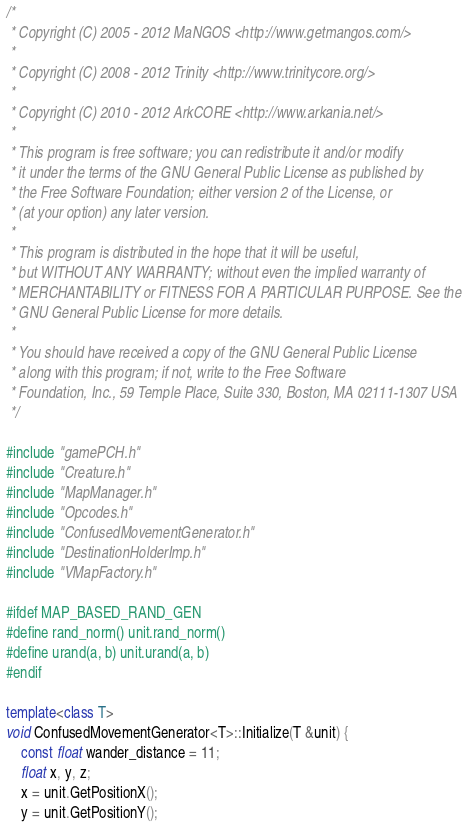Convert code to text. <code><loc_0><loc_0><loc_500><loc_500><_C++_>/*
 * Copyright (C) 2005 - 2012 MaNGOS <http://www.getmangos.com/>
 *
 * Copyright (C) 2008 - 2012 Trinity <http://www.trinitycore.org/>
 *
 * Copyright (C) 2010 - 2012 ArkCORE <http://www.arkania.net/>
 *
 * This program is free software; you can redistribute it and/or modify
 * it under the terms of the GNU General Public License as published by
 * the Free Software Foundation; either version 2 of the License, or
 * (at your option) any later version.
 *
 * This program is distributed in the hope that it will be useful,
 * but WITHOUT ANY WARRANTY; without even the implied warranty of
 * MERCHANTABILITY or FITNESS FOR A PARTICULAR PURPOSE. See the
 * GNU General Public License for more details.
 *
 * You should have received a copy of the GNU General Public License
 * along with this program; if not, write to the Free Software
 * Foundation, Inc., 59 Temple Place, Suite 330, Boston, MA 02111-1307 USA
 */

#include "gamePCH.h"
#include "Creature.h"
#include "MapManager.h"
#include "Opcodes.h"
#include "ConfusedMovementGenerator.h"
#include "DestinationHolderImp.h"
#include "VMapFactory.h"

#ifdef MAP_BASED_RAND_GEN
#define rand_norm() unit.rand_norm()
#define urand(a, b) unit.urand(a, b)
#endif

template<class T>
void ConfusedMovementGenerator<T>::Initialize(T &unit) {
	const float wander_distance = 11;
	float x, y, z;
	x = unit.GetPositionX();
	y = unit.GetPositionY();</code> 